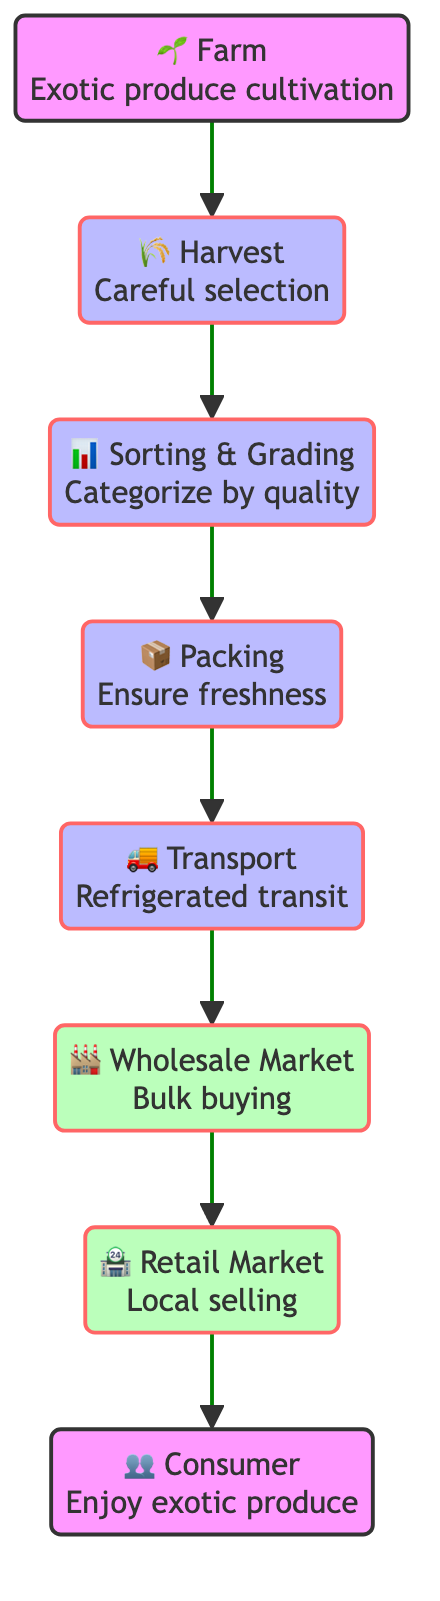What is the first step in the supply chain for exotic produce? The diagram indicates that the first step is the "Farm," where the cultivation of exotic produce takes place.
Answer: Farm How many main processes are involved in the supply chain? By counting the nodes categorized as processes (harvest, sorting, packing, transport), there are four main processes involved in the supply chain.
Answer: 4 What connects 'harvest' to 'sorting'? The connection between 'harvest' and 'sorting' is through a one-directional arrow indicating that harvesting leads directly to the sorting step.
Answer: sorting What type of produce is cultivated on the farm? The description for the farm mentions "exotic produce" like dragon fruit, mangosteen, and purple carrots.
Answer: Exotic produce Which market follows after the 'wholesale' stage? According to the flow chart, 'retail' market directly follows the 'wholesale' stage, indicating the next level of distribution.
Answer: Retail Market What is the purpose of the 'packing' process? The packing process is described as ensuring freshness and preventing damage to the produce, which is crucial for maintaining quality during transportation.
Answer: Ensure freshness How does the transport system maintain produce quality? The diagram states that the 'Transport' process utilizes refrigerated transportation, which is essential for maintaining the quality of exotic produce during transit.
Answer: Refrigerated transportation Why is 'sorting' important in the supply chain? The 'sorting' step categorizes produce based on size, quality, and ripeness, ensuring only the best items move forward in the supply chain to meet market standards.
Answer: Categorizing produce What type of consumers purchase the exotic produce? The diagram labels the last node as 'Consumer,' which signifies that these are end customers who purchase and enjoy the unique and exotic produce.
Answer: Consumer 